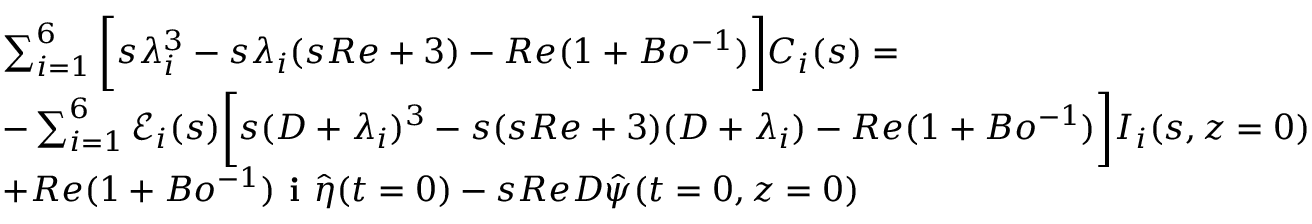<formula> <loc_0><loc_0><loc_500><loc_500>\begin{array} { r l } & { \sum _ { i = 1 } ^ { 6 } \left [ s \lambda _ { i } ^ { 3 } - s \lambda _ { i } ( s R e + 3 ) - R e ( 1 + B o ^ { - 1 } ) \right ] C _ { i } ( s ) = } \\ & { - \sum _ { i = 1 } ^ { 6 } \ m a t h s c r { E } _ { i } ( s ) \left [ s ( D + \lambda _ { i } ) ^ { 3 } - s ( s R e + 3 ) ( D + \lambda _ { i } ) - R e ( 1 + B o ^ { - 1 } ) \right ] I _ { i } ( s , z = 0 ) } \\ & { + R e ( 1 + B o ^ { - 1 } ) i \hat { \eta } ( t = 0 ) - s R e D \hat { \psi } ( t = 0 , z = 0 ) } \end{array}</formula> 